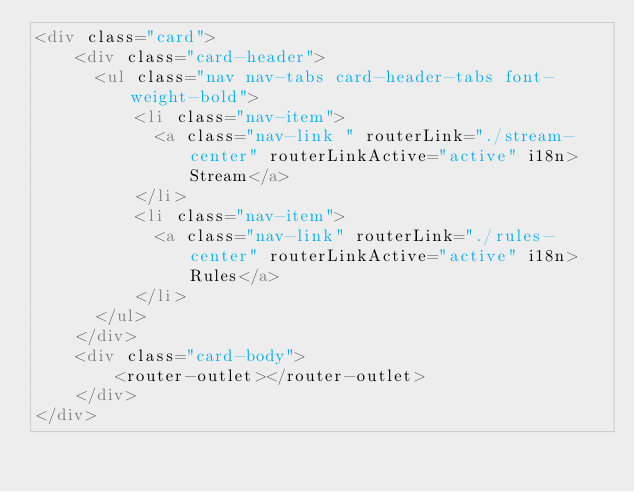<code> <loc_0><loc_0><loc_500><loc_500><_HTML_><div class="card">
    <div class="card-header">
      <ul class="nav nav-tabs card-header-tabs font-weight-bold">
          <li class="nav-item">
            <a class="nav-link " routerLink="./stream-center" routerLinkActive="active" i18n>Stream</a>
          </li>
          <li class="nav-item">
            <a class="nav-link" routerLink="./rules-center" routerLinkActive="active" i18n>Rules</a>
          </li>
      </ul>
    </div>
    <div class="card-body">
        <router-outlet></router-outlet>
    </div>
</div></code> 